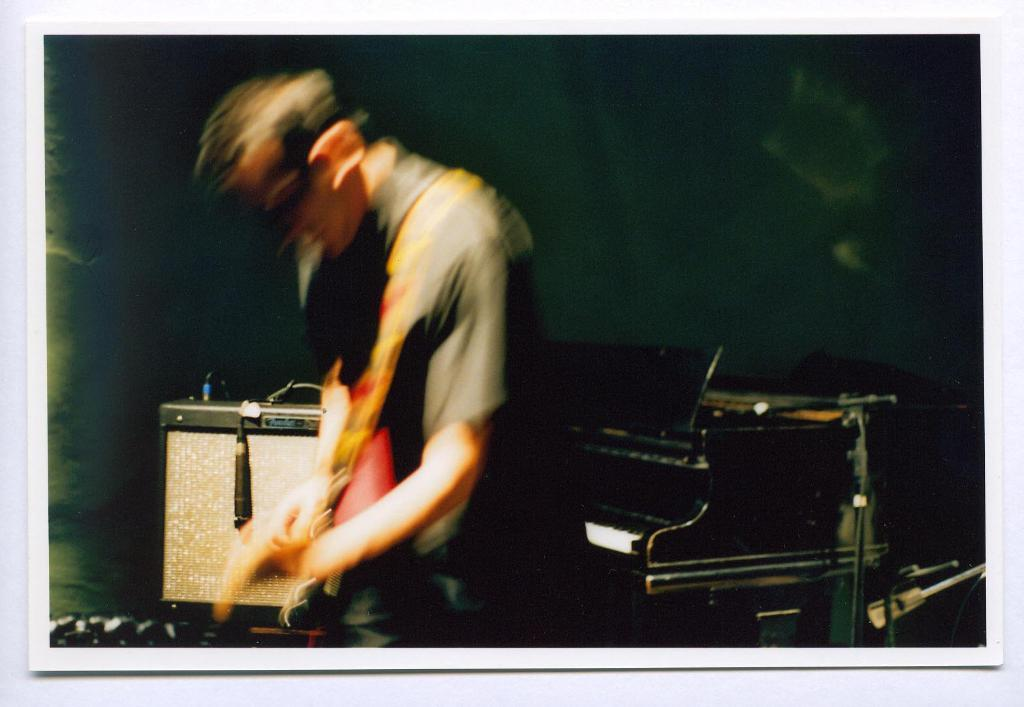What is the main subject of the image? There is a man standing in the image. What can be seen in the background of the image? There is a table in the background of the image. Where was the image likely taken? The image appears to be taken inside a room. What type of fuel is being used by the man in the image? There is no indication in the image that the man is using any type of fuel. 